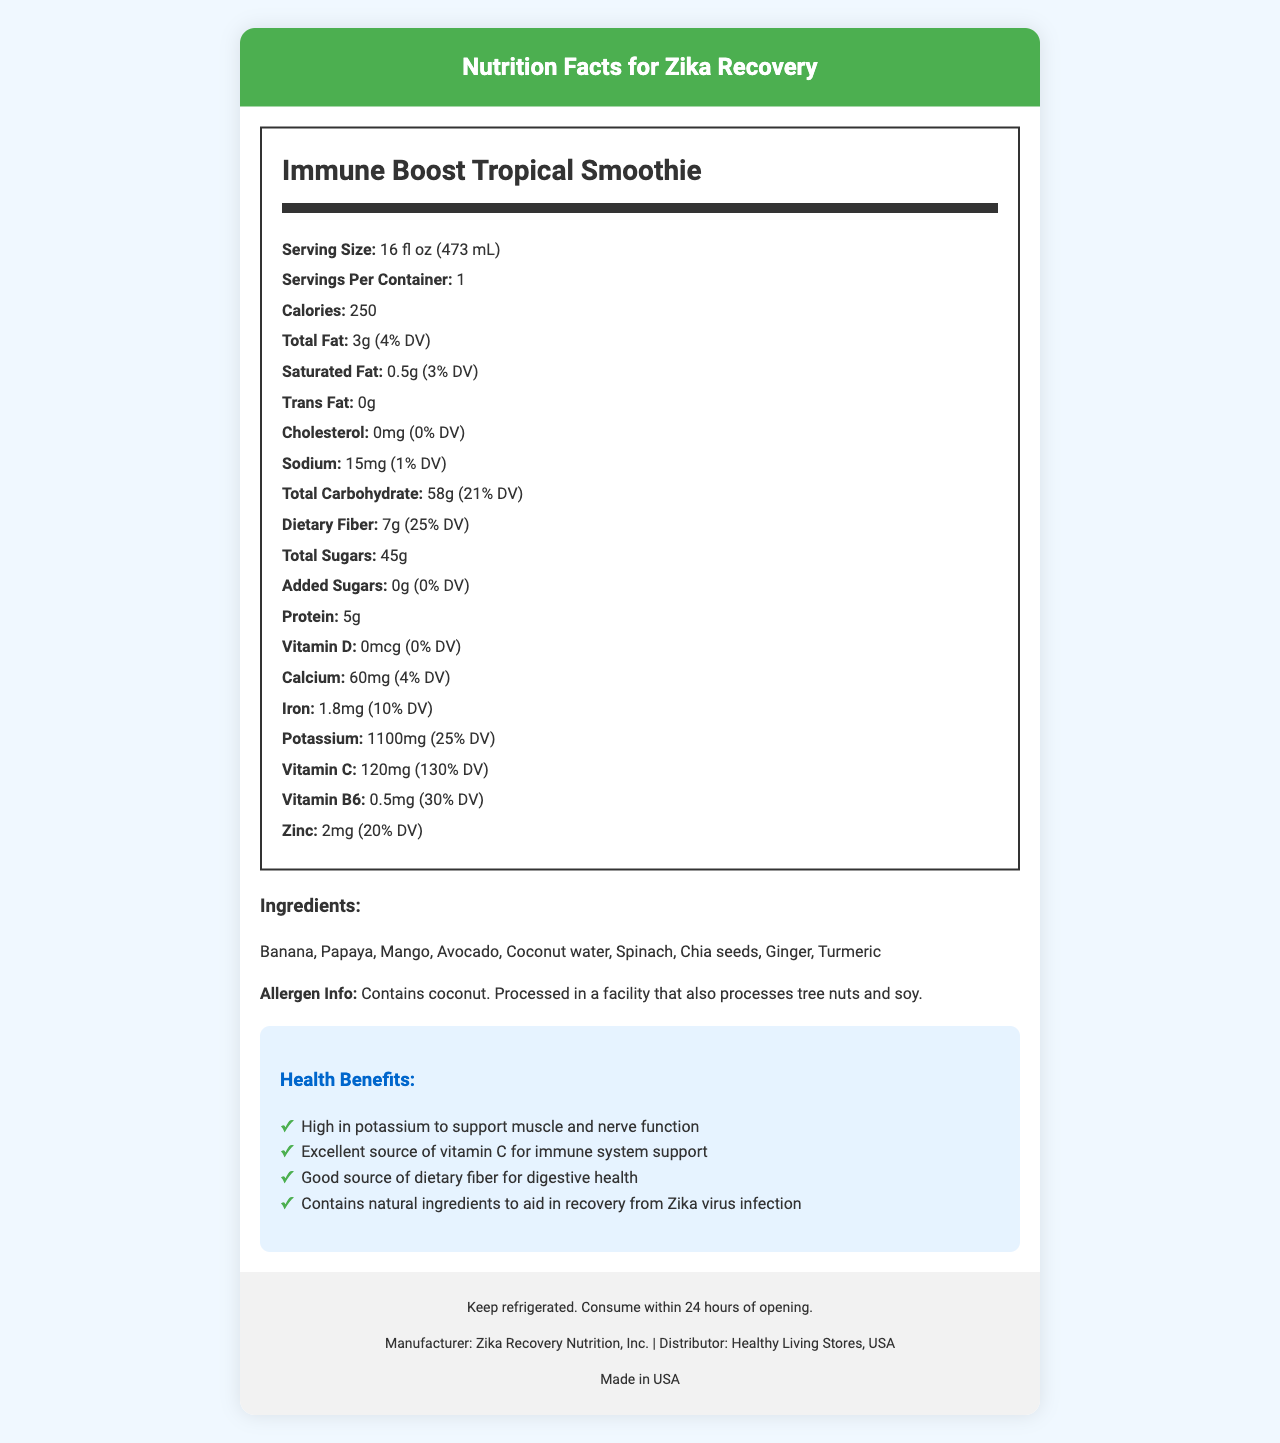what is the serving size for the Immune Boost Tropical Smoothie? The document states that the serving size is 16 fl oz (473 mL).
Answer: 16 fl oz (473 mL) how many milligrams of potassium does the Immune Boost Tropical Smoothie contain? According to the document, the smoothie contains 1100mg of potassium.
Answer: 1100mg does the Immune Boost Tropical Smoothie contain any trans fat? The document indicates that the smoothie contains 0g of trans fat.
Answer: No what is the primary distributor of this product? The distributor information at the bottom of the document lists Healthy Living Stores, USA as the distributor.
Answer: Healthy Living Stores, USA what type of facility is the Immune Boost Tropical Smoothie processed in? The allergen information mentions that it is processed in a facility that also processes tree nuts and soy.
Answer: A facility that also processes tree nuts and soy how soon after opening should the Immune Boost Tropical Smoothie be consumed? The storage instructions advise consuming the smoothie within 24 hours of opening.
Answer: Within 24 hours how much dietary fiber is in one serving of the Immune Boost Tropical Smoothie? The nutrition label shows that each serving contains 7g of dietary fiber.
Answer: 7g which vitamin is present in the highest percentage of daily value? The smoothie provides 130% DV of vitamin C, which is the highest percentage among the listed vitamins and minerals.
Answer: Vitamin C what are the main ingredients of the Immune Boost Tropical Smoothie? The ingredients section lists these items as the main ingredients.
Answer: Banana, Papaya, Mango, Avocado, Coconut water, Spinach, Chia seeds, Ginger, Turmeric which of the following statements is a health claim made about the Immune Boost Tropical Smoothie? A. Supports weight loss B. Supports muscle and nerve function C. Lowers blood pressure D. Improves vision The health claim section mentions that the smoothie is "High in potassium to support muscle and nerve function."
Answer: B how many grams of total sugars are in a single serving of the smoothie? The nutrition label indicates that there are 45g of total sugars in a single serving.
Answer: 45g is the Immune Boost Tropical Smoothie a good source of protein? While the smoothie contains 5g of protein, the document does not highlight it as a significant source compared to other nutrients.
Answer: No what nutrient in the smoothie contributes to its immune system support claim? The health benefit section claims that the smoothie is an excellent source of vitamin C, which supports the immune system.
Answer: Vitamin C list all the health benefits mentioned in the document for the Immune Boost Tropical Smoothie. The health claims section lists these specific benefits.
Answer: High in potassium to support muscle and nerve function; Excellent source of vitamin C for immune system support; Good source of dietary fiber for digestive health; Contains natural ingredients to aid in recovery from Zika virus infection which company manufactures the Immune Boost Tropical Smoothie? A. Healthy Living Stores, USA B. Zika Recovery Nutrition, Inc. C. USA Health Co. D. Tropical Delight Smoothies The manufacturer information at the bottom of the document shows Zika Recovery Nutrition, Inc. as the manufacturer.
Answer: B how many calories are in a serving of the Immune Boost Tropical Smoothie? The document lists the calorie count as 250 per serving.
Answer: 250 can you find the amount of vitamin A in the Immune Boost Tropical Smoothie? The document does not provide information on the amount of vitamin A in the smoothie.
Answer: Cannot be determined summarize the main idea of the document. The document is a comprehensive nutrition facts label highlighting the key nutrients, ingredients, health benefits, and storage instructions for the indicated smoothie product.
Answer: The document provides detailed nutrition facts and health benefits for "Immune Boost Tropical Smoothie," a product developed to support recovery from Zika virus infection. It contains essential nutrients like potassium, vitamin C, and dietary fiber, and emphasizes its natural ingredients and allergen information. 